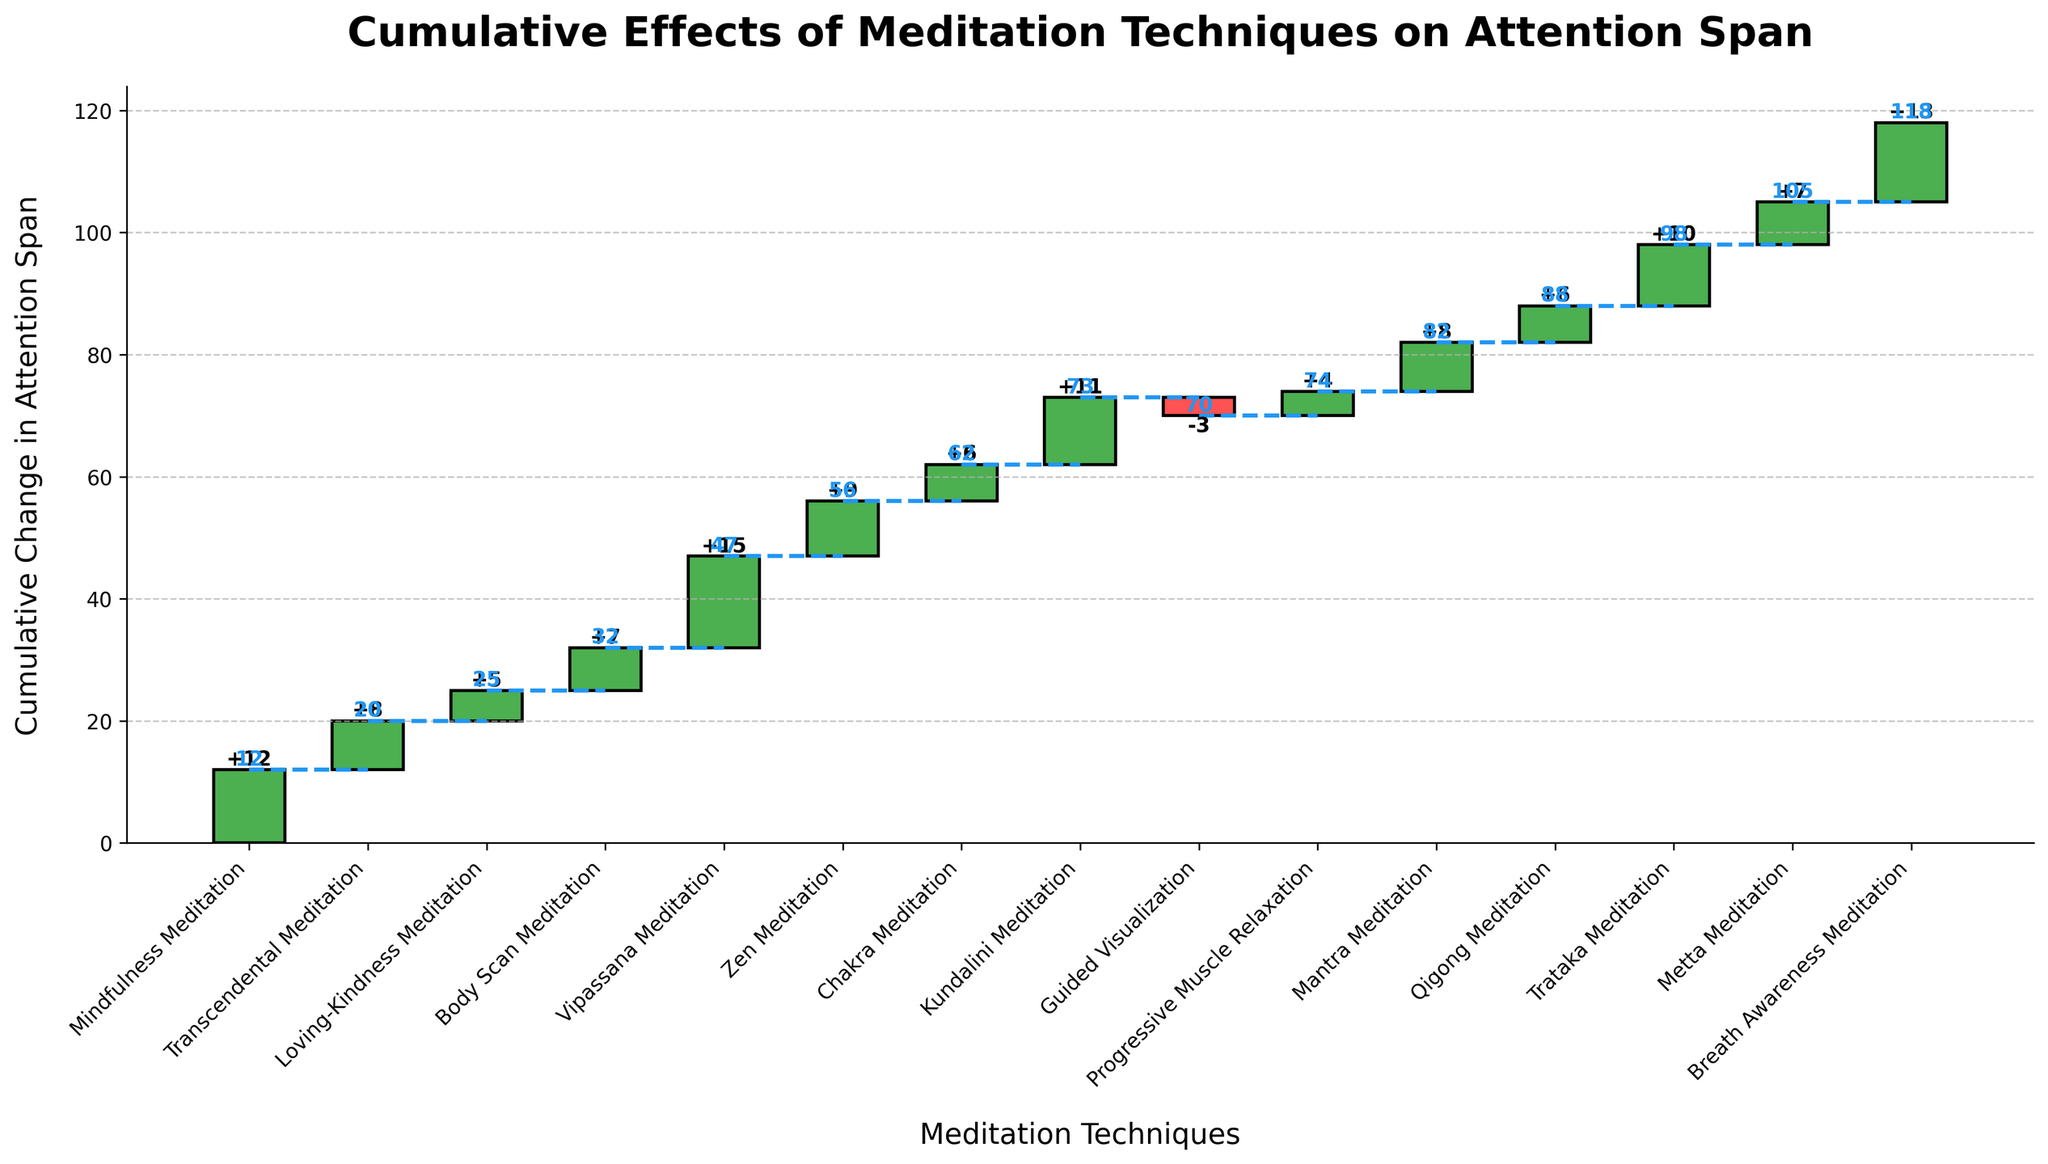What's the title of the figure? The title is usually displayed at the top of the chart, summarizing the content. Here, the title is "Cumulative Effects of Meditation Techniques on Attention Span."
Answer: Cumulative Effects of Meditation Techniques on Attention Span How many meditation techniques are displayed on the chart? Each technique is represented by a bar in the chart. Counting the number of bars or x-axis labels gives the number of techniques.
Answer: 15 Which meditation technique shows the highest single increase in attention span? Look at the heights of the bars associated with increases in attention span. The technique with the tallest bar indicating an increase is Vipassana Meditation, with a 15-unit change.
Answer: Vipassana Meditation What is the cumulative effect of Progressive Muscle Relaxation? Read the cumulative value at the top of the bar for Progressive Muscle Relaxation.
Answer: 74 Which technique had a negative effect on attention span? Any downward-facing bar or bar starting from a higher cumulative value but ending at a lower one represents a negative effect. Here, Guided Visualization has a -3 change.
Answer: Guided Visualization What is the total cumulative effect after adding Mantra Meditation? Add the cumulative changes sequentially up to and including Mantra Meditation. The cumulative value for Mantra Meditation is 82.
Answer: 82 Which technique contributed an 11-unit increase in attention span? Identify the technique with a bar showing an 11-unit change. Kundalini Meditation increases attention span by 11 units.
Answer: Kundalini Meditation What's the cumulative effect after the first three meditation techniques? Sum the cumulative effects of the first three techniques: 12 (Mindfulness) + 8 (Transcendental) + 5 (Loving-Kindness) = 25.
Answer: 25 What is the average contribution to attention span per technique? Add all the changes and divide by the number of techniques. The total change is 118 over 15 techniques: 118 / 15 ≈ 7.87.
Answer: 7.87 How much difference does Breath Awareness Meditation make compared to Chakra Meditation? Calculate the difference in effect between the two techniques: 13 (Breath Awareness) - 6 (Chakra) = 7.
Answer: 7 